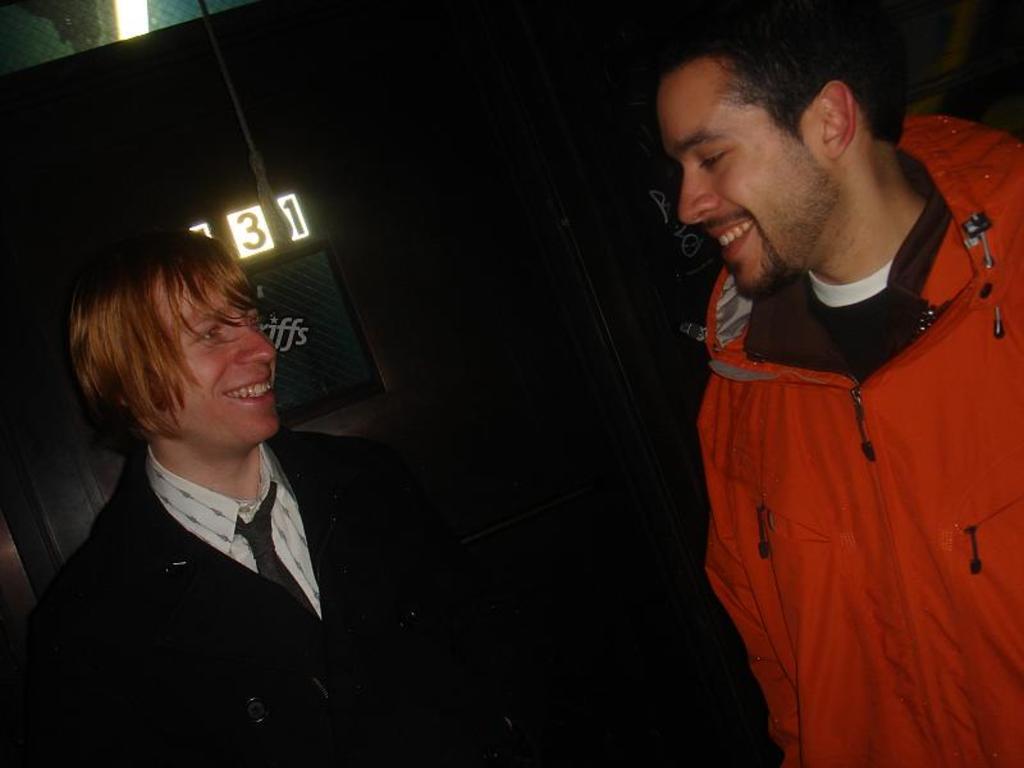In one or two sentences, can you explain what this image depicts? On the right side of the image we can see a man is standing and smiling and wearing a jacket. On the left side of the image we can see a man is standing and smiling and wearing a suit. In the background of the image we can see the wall, boards and text. 